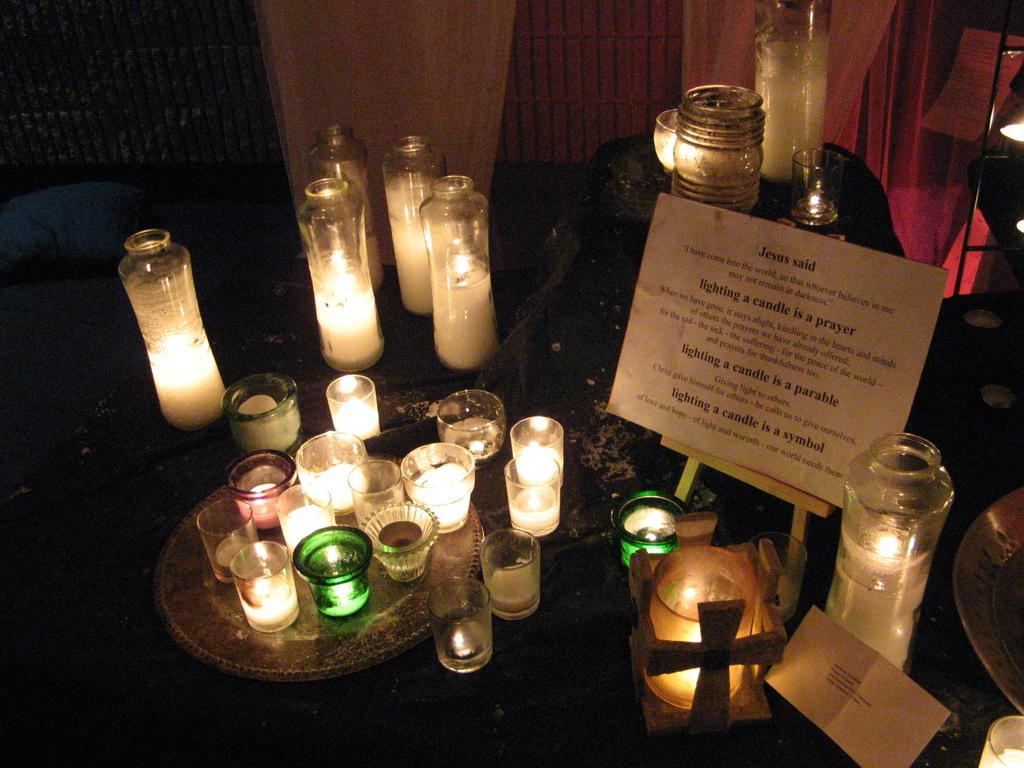How would you summarize this image in a sentence or two? In this image we can see the candles on the surface, we can see written text on the board, in the background we can see the curtains. 